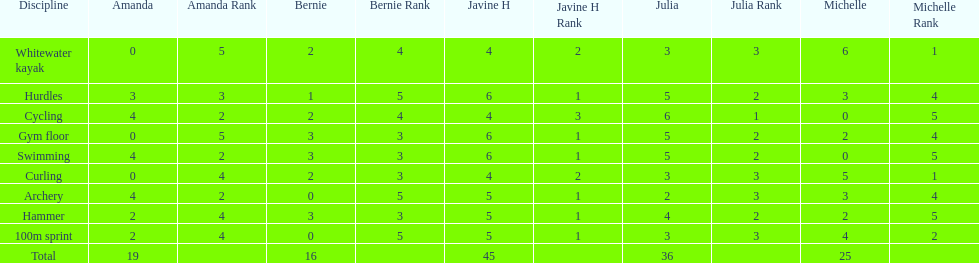Name a girl that had the same score in cycling and archery. Amanda. 